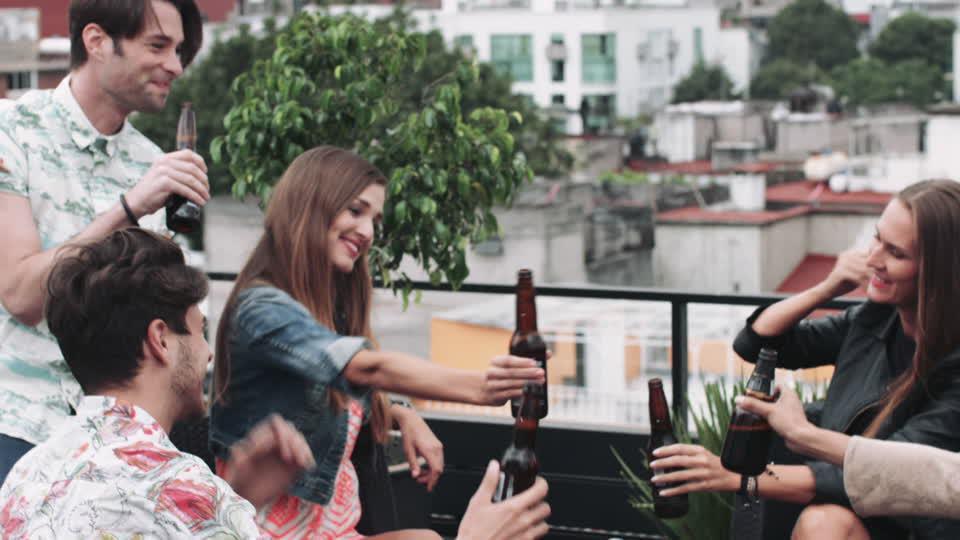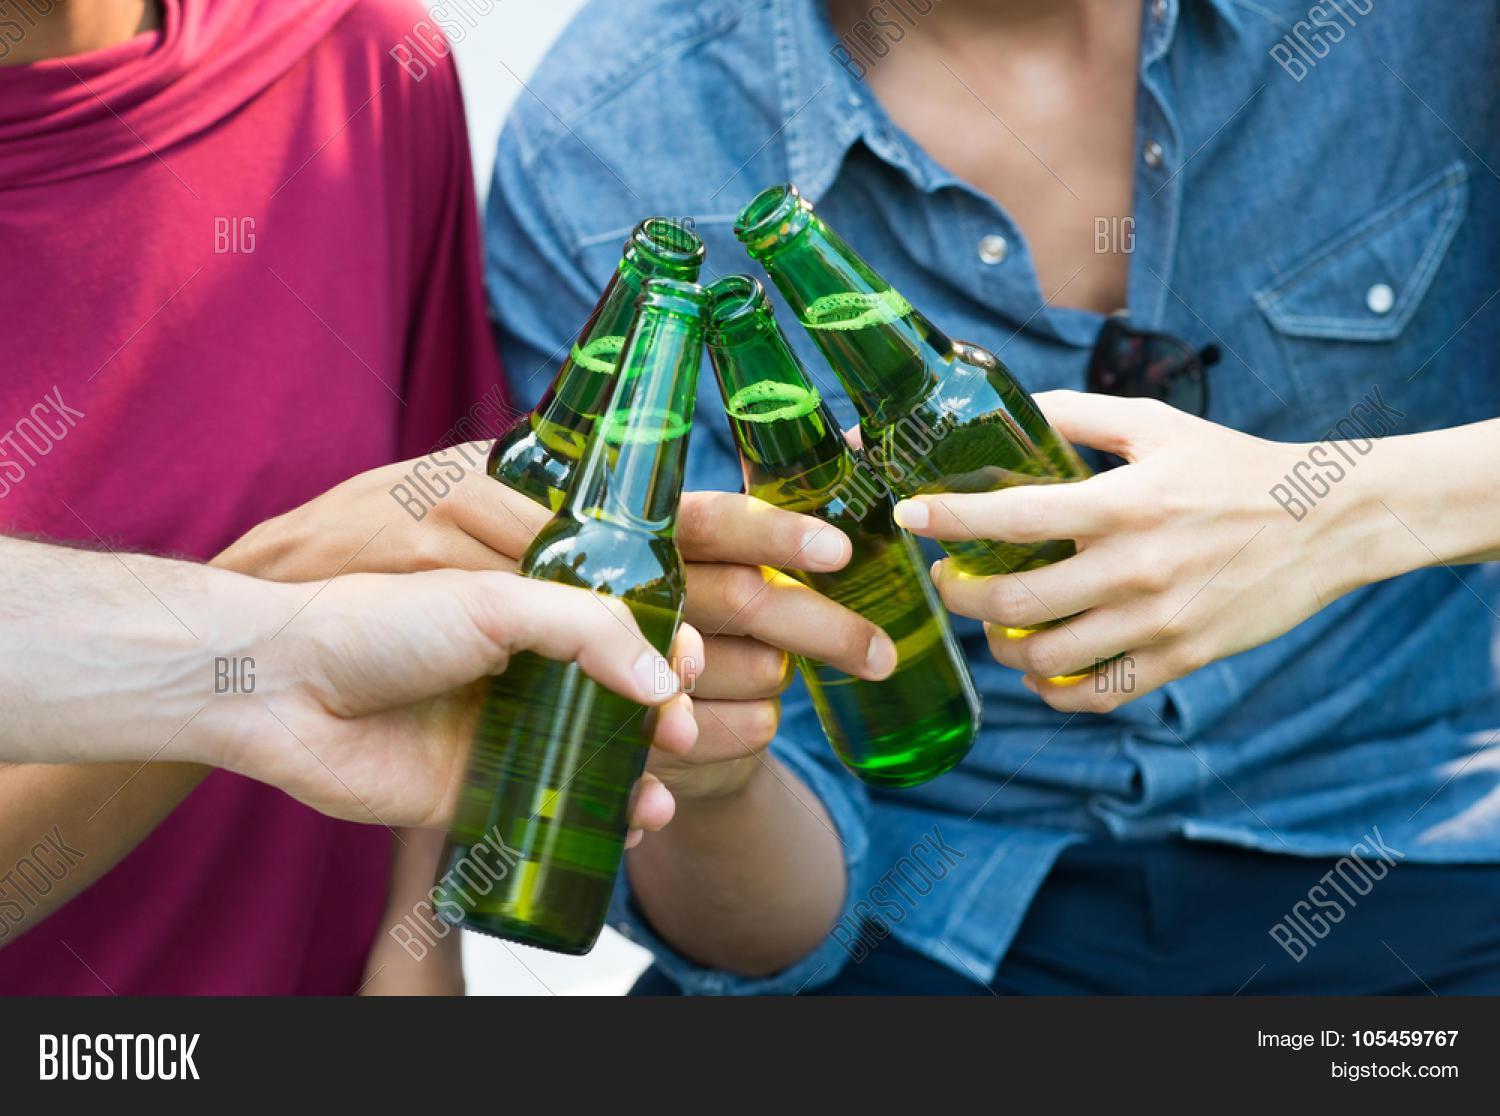The first image is the image on the left, the second image is the image on the right. For the images displayed, is the sentence "A woman is smiling and looking to the left in the left image of the pair." factually correct? Answer yes or no. Yes. The first image is the image on the left, the second image is the image on the right. For the images displayed, is the sentence "The right image shows two hands clinking two beer bottles together." factually correct? Answer yes or no. No. 